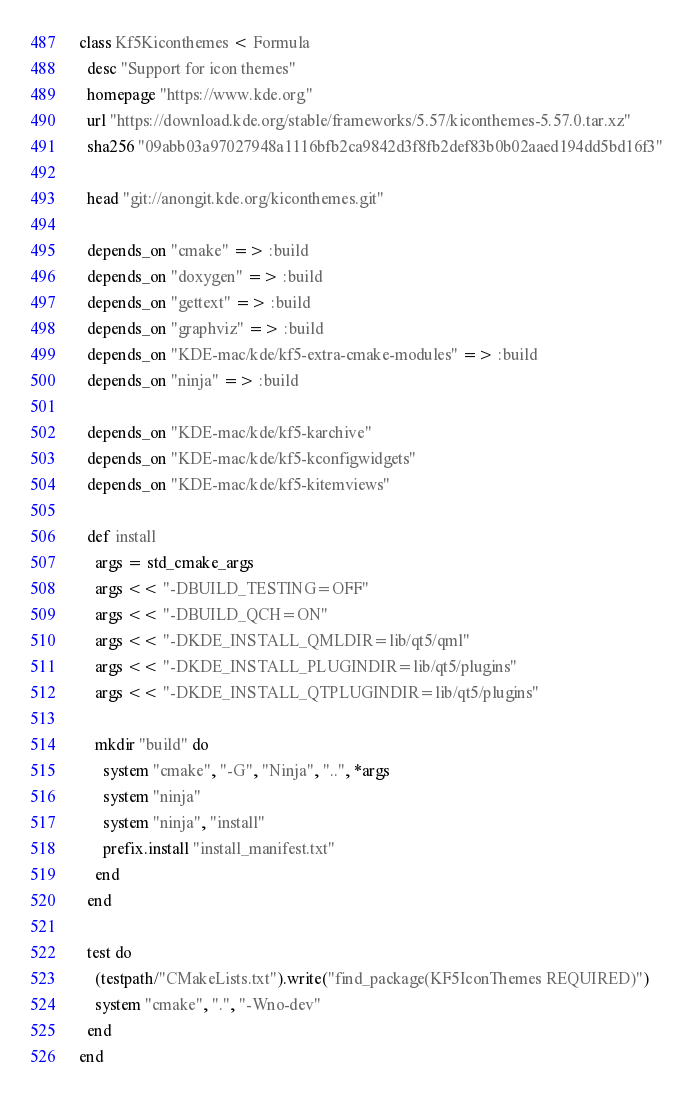<code> <loc_0><loc_0><loc_500><loc_500><_Ruby_>class Kf5Kiconthemes < Formula
  desc "Support for icon themes"
  homepage "https://www.kde.org"
  url "https://download.kde.org/stable/frameworks/5.57/kiconthemes-5.57.0.tar.xz"
  sha256 "09abb03a97027948a1116bfb2ca9842d3f8fb2def83b0b02aaed194dd5bd16f3"

  head "git://anongit.kde.org/kiconthemes.git"

  depends_on "cmake" => :build
  depends_on "doxygen" => :build
  depends_on "gettext" => :build
  depends_on "graphviz" => :build
  depends_on "KDE-mac/kde/kf5-extra-cmake-modules" => :build
  depends_on "ninja" => :build

  depends_on "KDE-mac/kde/kf5-karchive"
  depends_on "KDE-mac/kde/kf5-kconfigwidgets"
  depends_on "KDE-mac/kde/kf5-kitemviews"

  def install
    args = std_cmake_args
    args << "-DBUILD_TESTING=OFF"
    args << "-DBUILD_QCH=ON"
    args << "-DKDE_INSTALL_QMLDIR=lib/qt5/qml"
    args << "-DKDE_INSTALL_PLUGINDIR=lib/qt5/plugins"
    args << "-DKDE_INSTALL_QTPLUGINDIR=lib/qt5/plugins"

    mkdir "build" do
      system "cmake", "-G", "Ninja", "..", *args
      system "ninja"
      system "ninja", "install"
      prefix.install "install_manifest.txt"
    end
  end

  test do
    (testpath/"CMakeLists.txt").write("find_package(KF5IconThemes REQUIRED)")
    system "cmake", ".", "-Wno-dev"
  end
end
</code> 